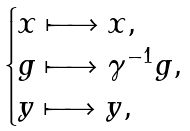Convert formula to latex. <formula><loc_0><loc_0><loc_500><loc_500>\begin{cases} x \longmapsto x , & \\ g \longmapsto \gamma ^ { - 1 } g , & \\ y \longmapsto y , & \end{cases}</formula> 